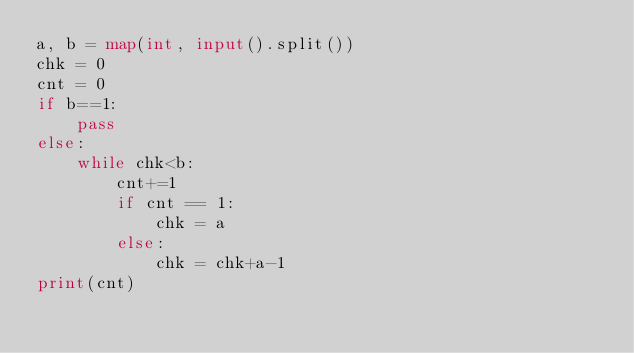Convert code to text. <code><loc_0><loc_0><loc_500><loc_500><_Python_>a, b = map(int, input().split())
chk = 0
cnt = 0
if b==1:
    pass
else:
    while chk<b:
        cnt+=1
        if cnt == 1:
            chk = a
        else:
            chk = chk+a-1
print(cnt)</code> 